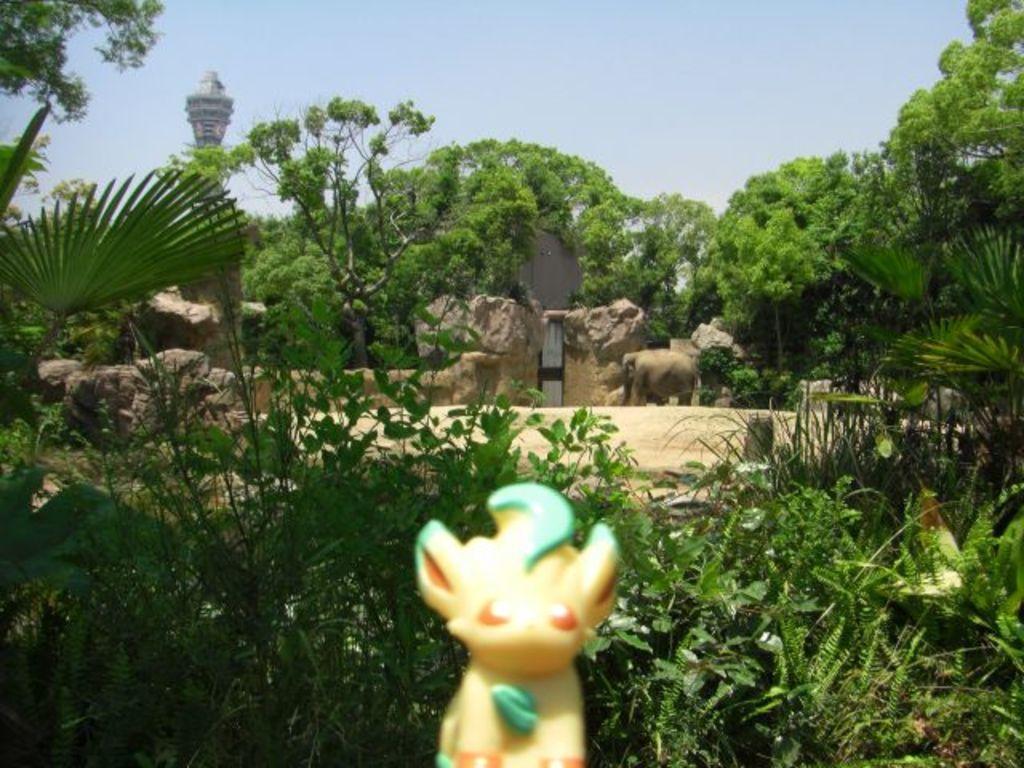Please provide a concise description of this image. In this image we can see a toy, few plants, trees, an elephant on the ground, a gate to the wall, a tower and the sky in the background. 